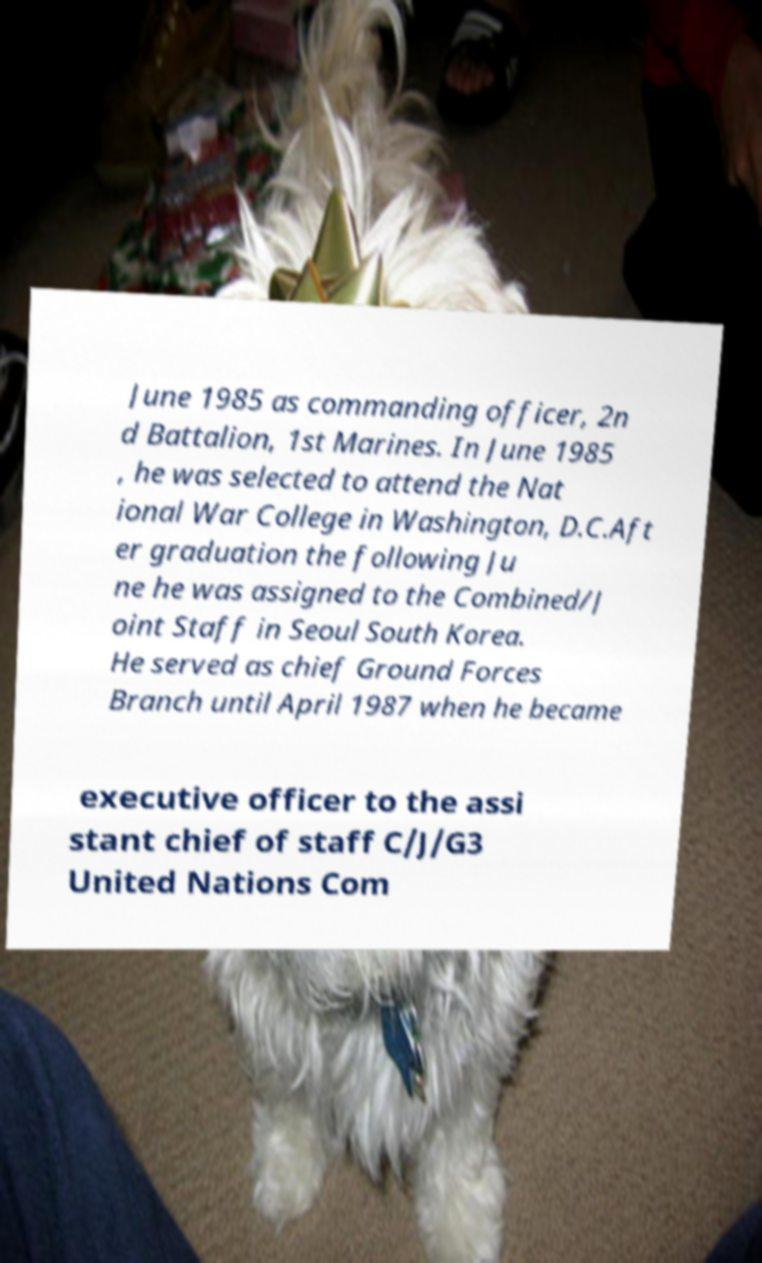Can you accurately transcribe the text from the provided image for me? June 1985 as commanding officer, 2n d Battalion, 1st Marines. In June 1985 , he was selected to attend the Nat ional War College in Washington, D.C.Aft er graduation the following Ju ne he was assigned to the Combined/J oint Staff in Seoul South Korea. He served as chief Ground Forces Branch until April 1987 when he became executive officer to the assi stant chief of staff C/J/G3 United Nations Com 